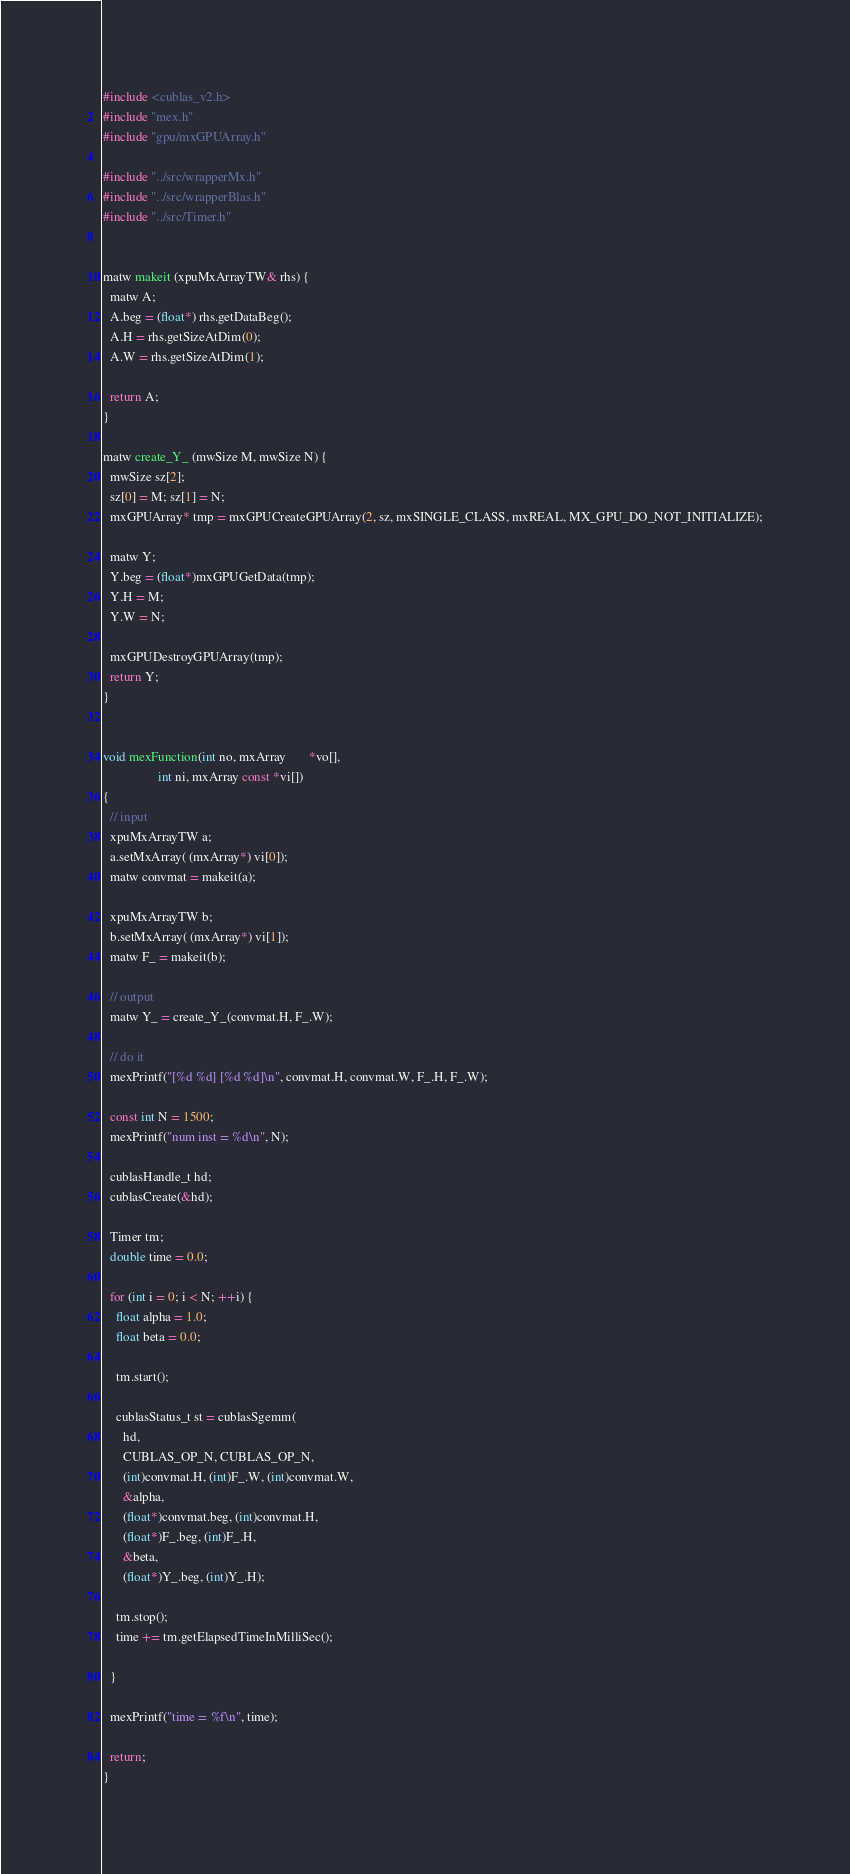<code> <loc_0><loc_0><loc_500><loc_500><_Cuda_>#include <cublas_v2.h>
#include "mex.h"
#include "gpu/mxGPUArray.h"

#include "../src/wrapperMx.h"
#include "../src/wrapperBlas.h"
#include "../src/Timer.h"


matw makeit (xpuMxArrayTW& rhs) {
  matw A;
  A.beg = (float*) rhs.getDataBeg();
  A.H = rhs.getSizeAtDim(0);
  A.W = rhs.getSizeAtDim(1);

  return A;
}

matw create_Y_ (mwSize M, mwSize N) {
  mwSize sz[2];
  sz[0] = M; sz[1] = N;
  mxGPUArray* tmp = mxGPUCreateGPUArray(2, sz, mxSINGLE_CLASS, mxREAL, MX_GPU_DO_NOT_INITIALIZE);

  matw Y;
  Y.beg = (float*)mxGPUGetData(tmp);
  Y.H = M;
  Y.W = N;

  mxGPUDestroyGPUArray(tmp);
  return Y;
}


void mexFunction(int no, mxArray       *vo[],
                 int ni, mxArray const *vi[])
{
  // input
  xpuMxArrayTW a;
  a.setMxArray( (mxArray*) vi[0]);
  matw convmat = makeit(a);

  xpuMxArrayTW b;
  b.setMxArray( (mxArray*) vi[1]);
  matw F_ = makeit(b);

  // output
  matw Y_ = create_Y_(convmat.H, F_.W);

  // do it
  mexPrintf("[%d %d] [%d %d]\n", convmat.H, convmat.W, F_.H, F_.W);

  const int N = 1500;
  mexPrintf("num inst = %d\n", N);

  cublasHandle_t hd;
  cublasCreate(&hd);

  Timer tm;
  double time = 0.0;

  for (int i = 0; i < N; ++i) {
    float alpha = 1.0;
    float beta = 0.0;

    tm.start();

    cublasStatus_t st = cublasSgemm(
      hd,
      CUBLAS_OP_N, CUBLAS_OP_N,
      (int)convmat.H, (int)F_.W, (int)convmat.W,
      &alpha,
      (float*)convmat.beg, (int)convmat.H,
      (float*)F_.beg, (int)F_.H,
      &beta,
      (float*)Y_.beg, (int)Y_.H);

    tm.stop();
    time += tm.getElapsedTimeInMilliSec();
    
  }

  mexPrintf("time = %f\n", time);
  
  return;
}</code> 